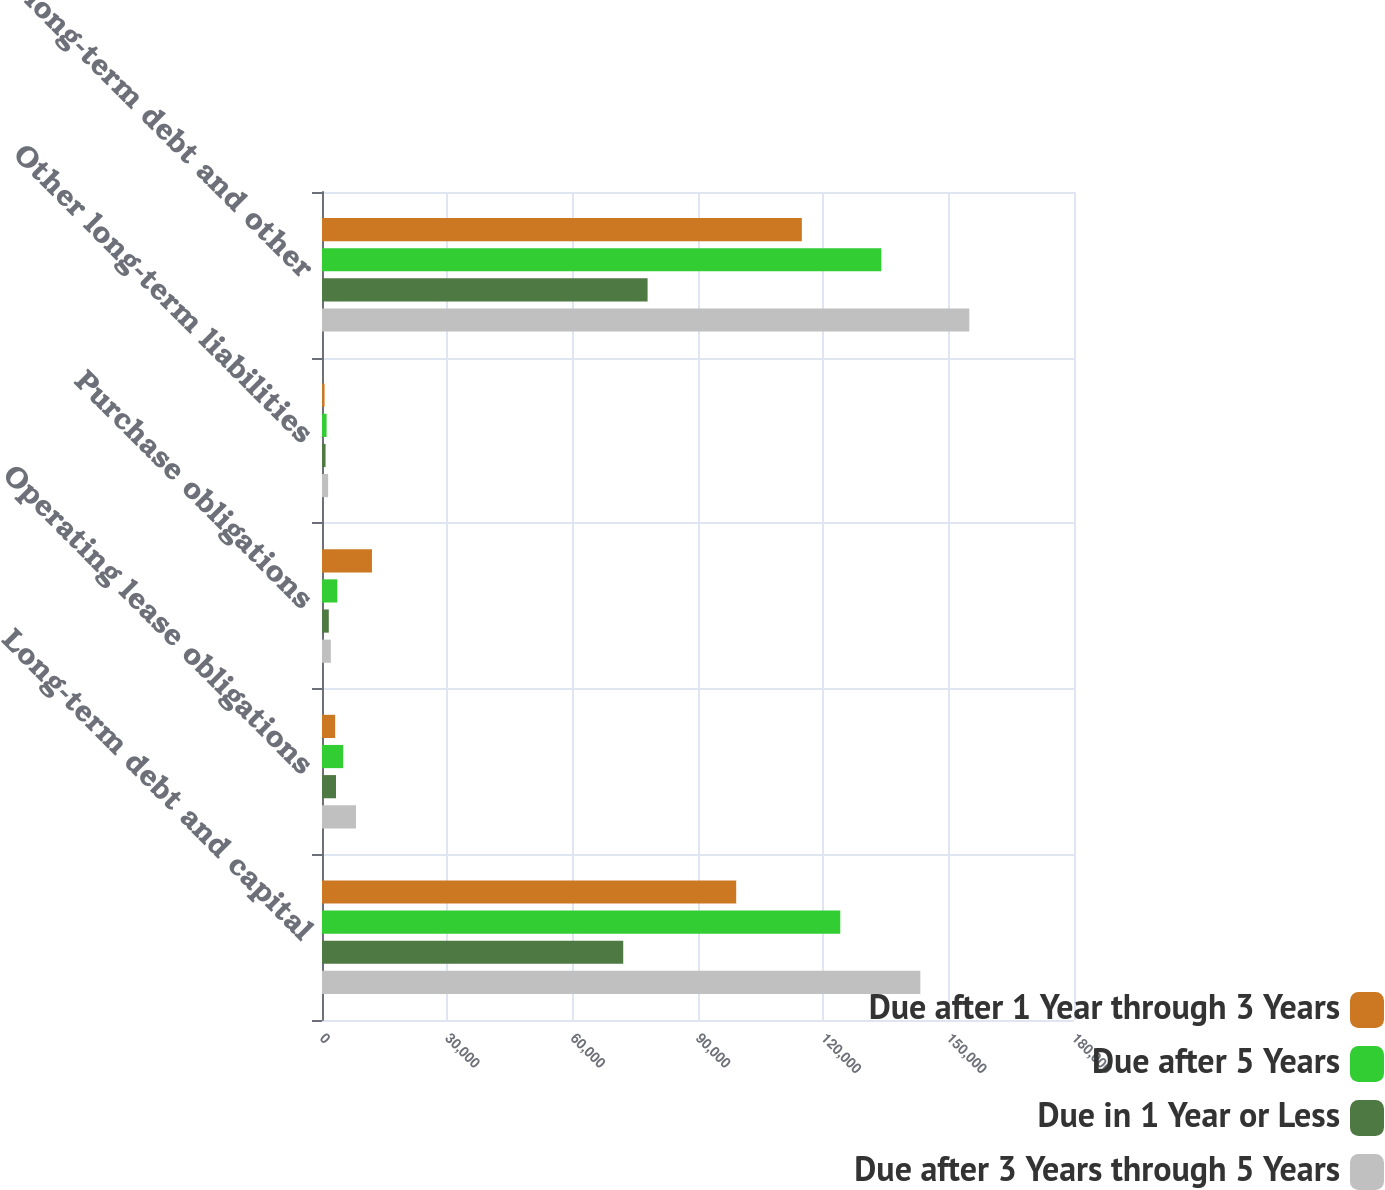Convert chart to OTSL. <chart><loc_0><loc_0><loc_500><loc_500><stacked_bar_chart><ecel><fcel>Long-term debt and capital<fcel>Operating lease obligations<fcel>Purchase obligations<fcel>Other long-term liabilities<fcel>Total long-term debt and other<nl><fcel>Due after 1 Year through 3 Years<fcel>99144<fcel>3143<fcel>11957<fcel>610<fcel>114854<nl><fcel>Due after 5 Years<fcel>124054<fcel>5072<fcel>3667<fcel>1097<fcel>133890<nl><fcel>Due in 1 Year or Less<fcel>72103<fcel>3355<fcel>1627<fcel>848<fcel>77933<nl><fcel>Due after 3 Years through 5 Years<fcel>143220<fcel>8143<fcel>2119<fcel>1464<fcel>154946<nl></chart> 